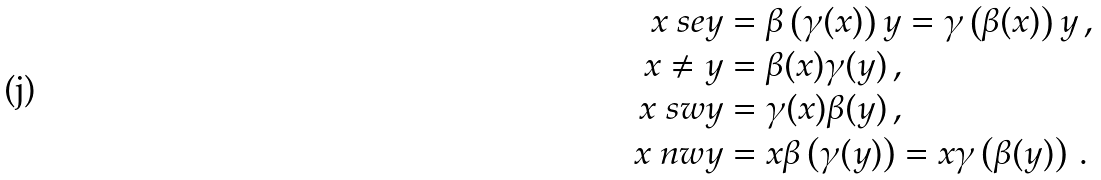Convert formula to latex. <formula><loc_0><loc_0><loc_500><loc_500>x \ s e y & = \beta \left ( \gamma ( x ) \right ) y = \gamma \left ( \beta ( x ) \right ) y \, , \\ x \ne y & = \beta ( x ) \gamma ( y ) \, , \\ x \ s w y & = \gamma ( x ) \beta ( y ) \, , \\ x \ n w y & = x \beta \left ( \gamma ( y ) \right ) = x \gamma \left ( \beta ( y ) \right ) \, .</formula> 